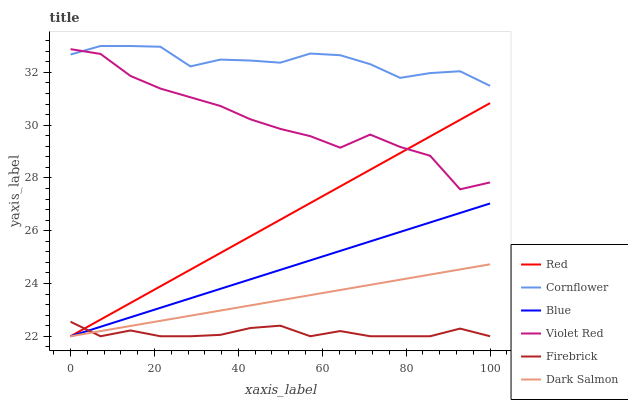Does Violet Red have the minimum area under the curve?
Answer yes or no. No. Does Violet Red have the maximum area under the curve?
Answer yes or no. No. Is Cornflower the smoothest?
Answer yes or no. No. Is Cornflower the roughest?
Answer yes or no. No. Does Violet Red have the lowest value?
Answer yes or no. No. Does Violet Red have the highest value?
Answer yes or no. No. Is Firebrick less than Violet Red?
Answer yes or no. Yes. Is Violet Red greater than Blue?
Answer yes or no. Yes. Does Firebrick intersect Violet Red?
Answer yes or no. No. 